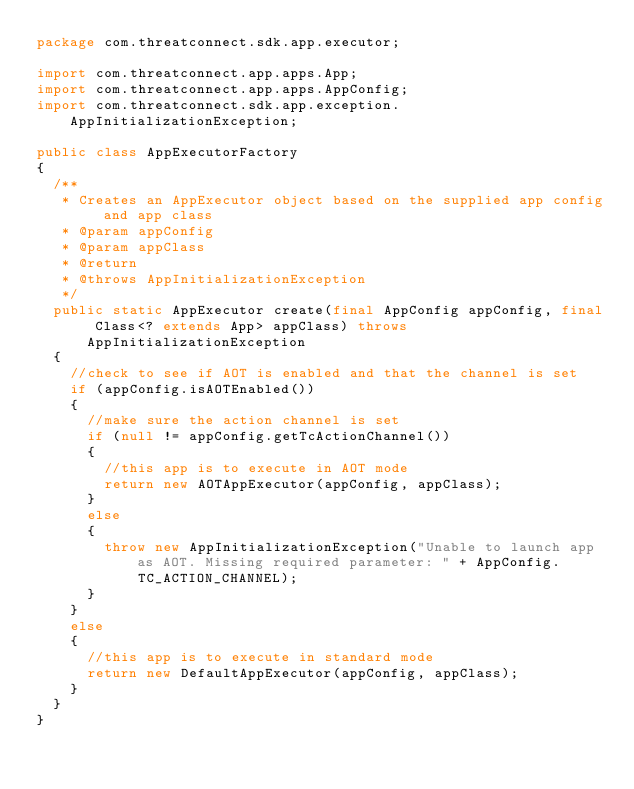<code> <loc_0><loc_0><loc_500><loc_500><_Java_>package com.threatconnect.sdk.app.executor;

import com.threatconnect.app.apps.App;
import com.threatconnect.app.apps.AppConfig;
import com.threatconnect.sdk.app.exception.AppInitializationException;

public class AppExecutorFactory
{
	/**
	 * Creates an AppExecutor object based on the supplied app config and app class
	 * @param appConfig
	 * @param appClass
	 * @return
	 * @throws AppInitializationException
	 */
	public static AppExecutor create(final AppConfig appConfig, final Class<? extends App> appClass) throws AppInitializationException
	{
		//check to see if AOT is enabled and that the channel is set
		if (appConfig.isAOTEnabled())
		{
			//make sure the action channel is set
			if (null != appConfig.getTcActionChannel())
			{
				//this app is to execute in AOT mode
				return new AOTAppExecutor(appConfig, appClass);
			}
			else
			{
				throw new AppInitializationException("Unable to launch app as AOT. Missing required parameter: " + AppConfig.TC_ACTION_CHANNEL);
			}
		}
		else
		{
			//this app is to execute in standard mode
			return new DefaultAppExecutor(appConfig, appClass);
		}
	}
}
</code> 